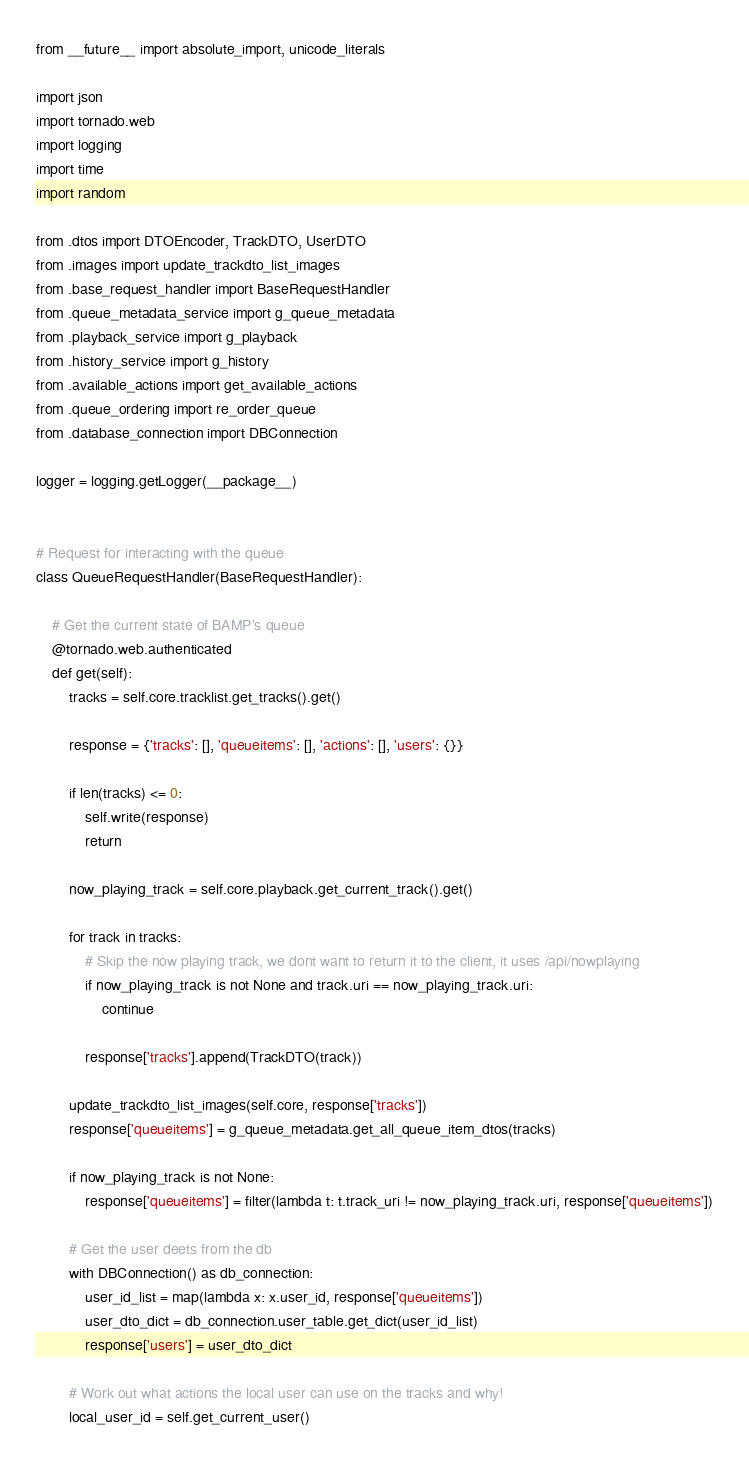<code> <loc_0><loc_0><loc_500><loc_500><_Python_>from __future__ import absolute_import, unicode_literals

import json
import tornado.web
import logging
import time
import random

from .dtos import DTOEncoder, TrackDTO, UserDTO
from .images import update_trackdto_list_images
from .base_request_handler import BaseRequestHandler
from .queue_metadata_service import g_queue_metadata
from .playback_service import g_playback
from .history_service import g_history
from .available_actions import get_available_actions
from .queue_ordering import re_order_queue
from .database_connection import DBConnection

logger = logging.getLogger(__package__)


# Request for interacting with the queue
class QueueRequestHandler(BaseRequestHandler):

    # Get the current state of BAMP's queue
    @tornado.web.authenticated
    def get(self):
        tracks = self.core.tracklist.get_tracks().get()

        response = {'tracks': [], 'queueitems': [], 'actions': [], 'users': {}}

        if len(tracks) <= 0:
            self.write(response)
            return

        now_playing_track = self.core.playback.get_current_track().get()

        for track in tracks:
            # Skip the now playing track, we dont want to return it to the client, it uses /api/nowplaying
            if now_playing_track is not None and track.uri == now_playing_track.uri:
                continue

            response['tracks'].append(TrackDTO(track))

        update_trackdto_list_images(self.core, response['tracks'])
        response['queueitems'] = g_queue_metadata.get_all_queue_item_dtos(tracks)

        if now_playing_track is not None:
            response['queueitems'] = filter(lambda t: t.track_uri != now_playing_track.uri, response['queueitems'])

        # Get the user deets from the db
        with DBConnection() as db_connection:
            user_id_list = map(lambda x: x.user_id, response['queueitems'])
            user_dto_dict = db_connection.user_table.get_dict(user_id_list)
            response['users'] = user_dto_dict

        # Work out what actions the local user can use on the tracks and why!
        local_user_id = self.get_current_user()
</code> 